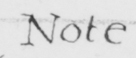Please transcribe the handwritten text in this image. Note . 